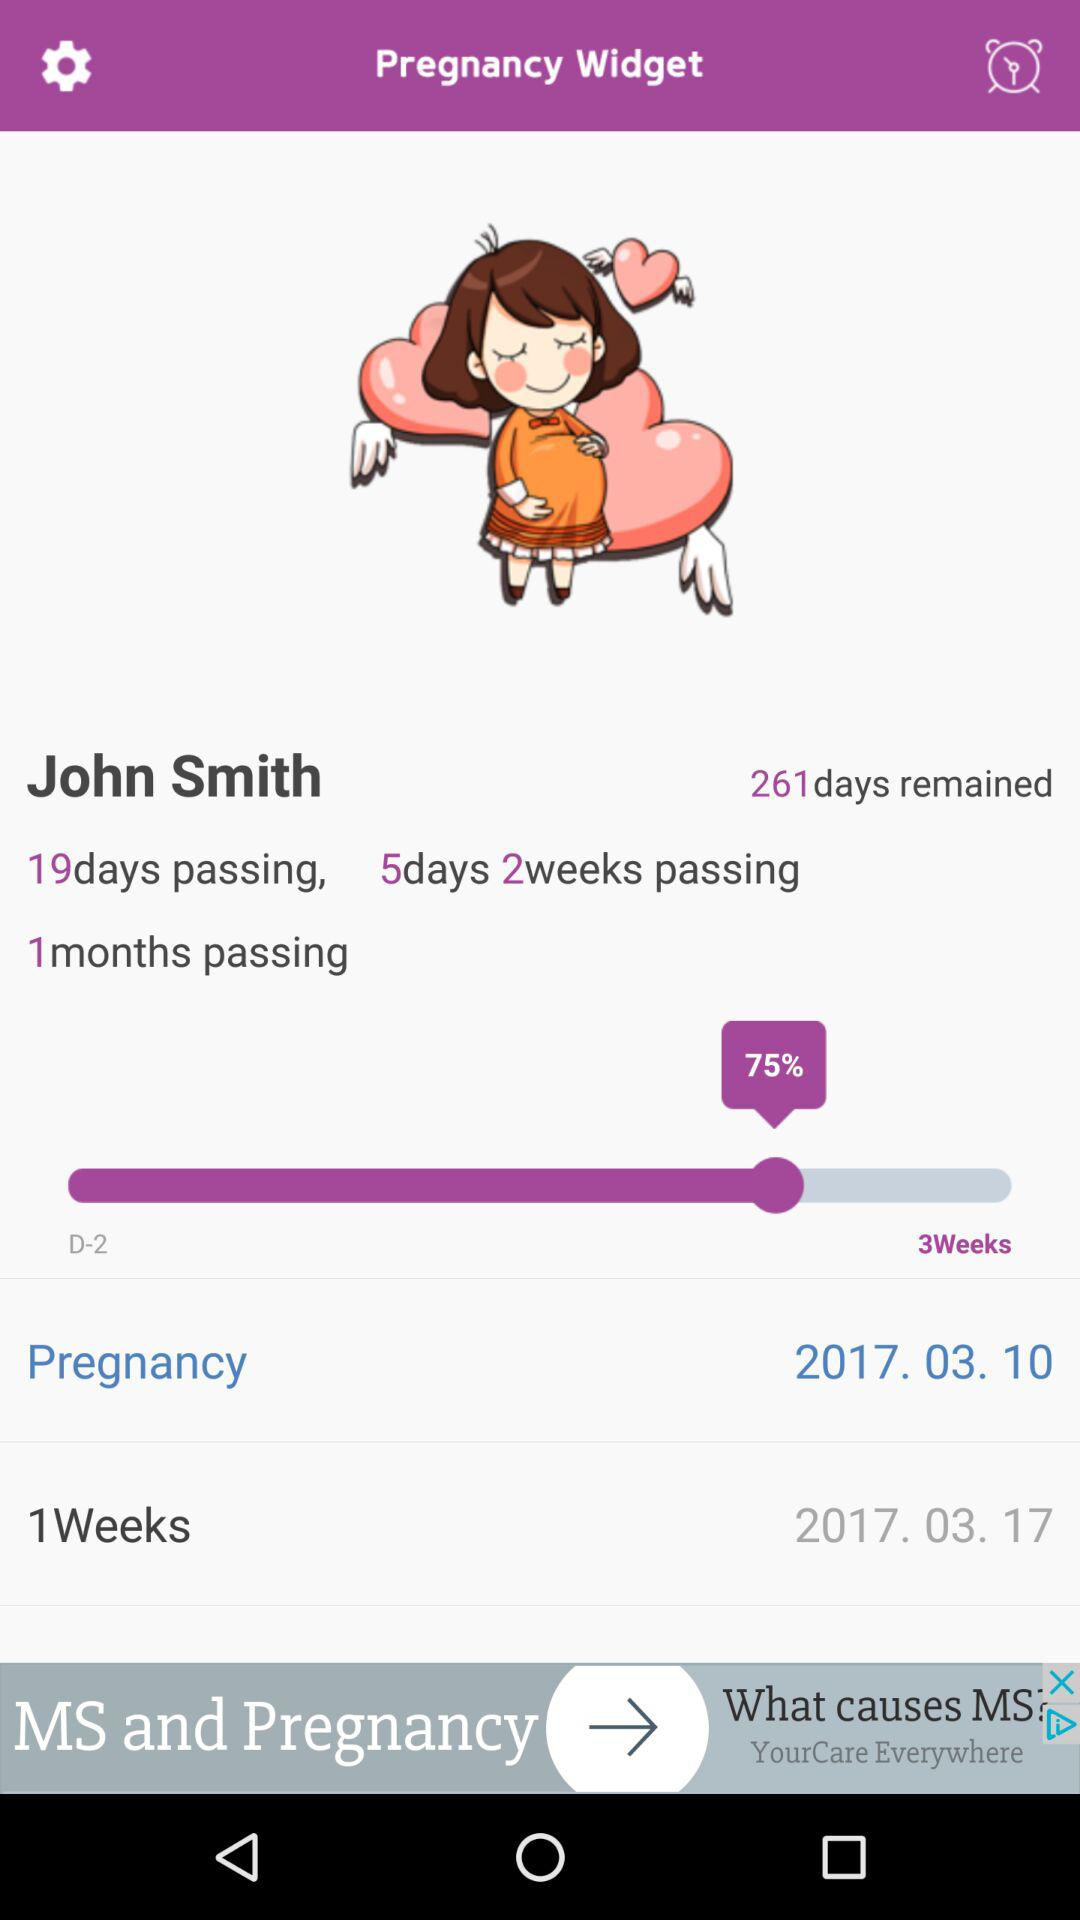What is the number of days and weeks? The number of days and weeks is 5 and 2, respectively. 